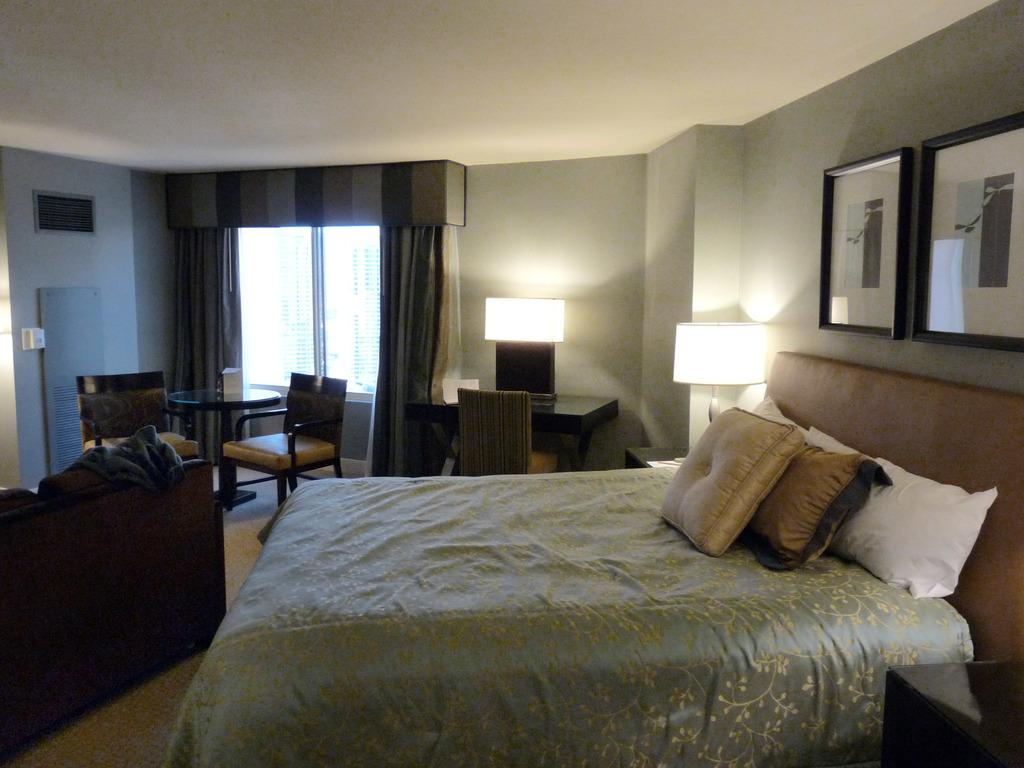What type of space is depicted in the image? There is a room in the image. What piece of furniture is present in the room? There is a bed in the room. How many lights are in the room? There are 2 lights in the room. Are there any seating options in the room? Yes, there are few chairs in the room. How many tables are in the room? There are 2 tables in the room. Is there a source of natural light in the room? Yes, there is a window in the room. What type of window treatment is present in the room? There are curtains associated with the window. Are there any decorative items on the wall? Yes, there are 2 photo frames on the wall. What type of food is being prepared on the wrist in the image? There is no wrist or food preparation visible in the image. 